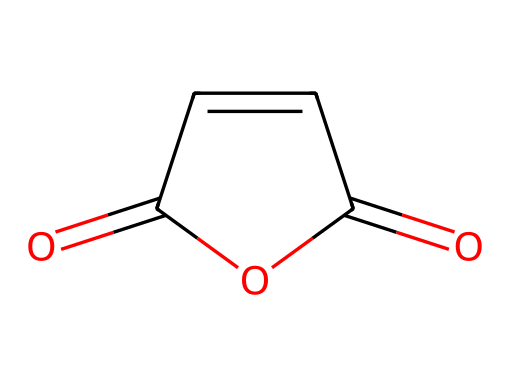What is the molecular formula of this compound? To determine the molecular formula, count the number of each type of atom from the SMILES notation. The structure contains 4 carbon atoms (C), 4 oxygen atoms (O), and 4 hydrogen atoms (H). Therefore, the molecular formula is C4H4O3.
Answer: C4H4O3 How many rings are present in the structure? Analyzing the SMILES representation, it shows a cyclic structure with one ring; specifically, there's one five-membered ring indicated by the 'C1' and 'C=C' connections.
Answer: 1 What type of functional groups are present in this chemical? The structure features both an anhydride (two carbonyl groups, O=C) and a double bond (C=C) indicating unsaturation. It confirms the presence of an acid anhydride functional group.
Answer: acid anhydride Which element has the highest electronegativity in this structure? Considering the common electronegativities of carbon, hydrogen, and oxygen, oxygen is the most electronegative element in this compound. Therefore, it pulls electron density toward itself, impacting overall reactivity.
Answer: oxygen What is the degree of unsaturation in this chemical? The degree of unsaturation can be calculated using the formula: (1 + C - H/2 - X/2 + N/2), where C = number of carbons, H = number of hydrogens, X = halogens, and N = nitrogens. For this structure (4 C, 4 H), the degree is 2, indicating two pi bonds or rings.
Answer: 2 Is this chemical likely to be soluble in water? Given the polar nature of the functional groups, particularly the carboxylic anhydride groups, this compound is expected to have moderate water solubility due to its ability to form hydrogen bonds with water.
Answer: moderately soluble 